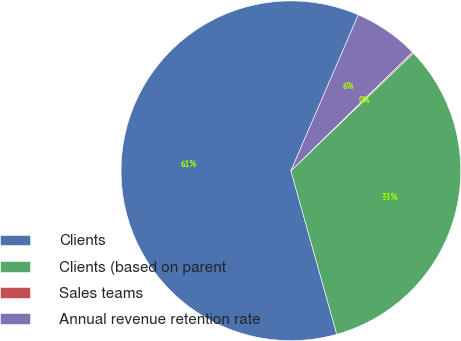Convert chart to OTSL. <chart><loc_0><loc_0><loc_500><loc_500><pie_chart><fcel>Clients<fcel>Clients (based on parent<fcel>Sales teams<fcel>Annual revenue retention rate<nl><fcel>60.84%<fcel>32.83%<fcel>0.13%<fcel>6.2%<nl></chart> 